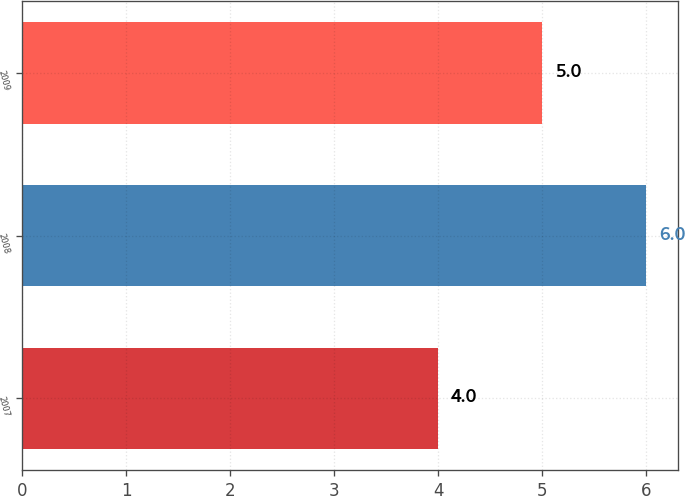Convert chart to OTSL. <chart><loc_0><loc_0><loc_500><loc_500><bar_chart><fcel>2007<fcel>2008<fcel>2009<nl><fcel>4<fcel>6<fcel>5<nl></chart> 